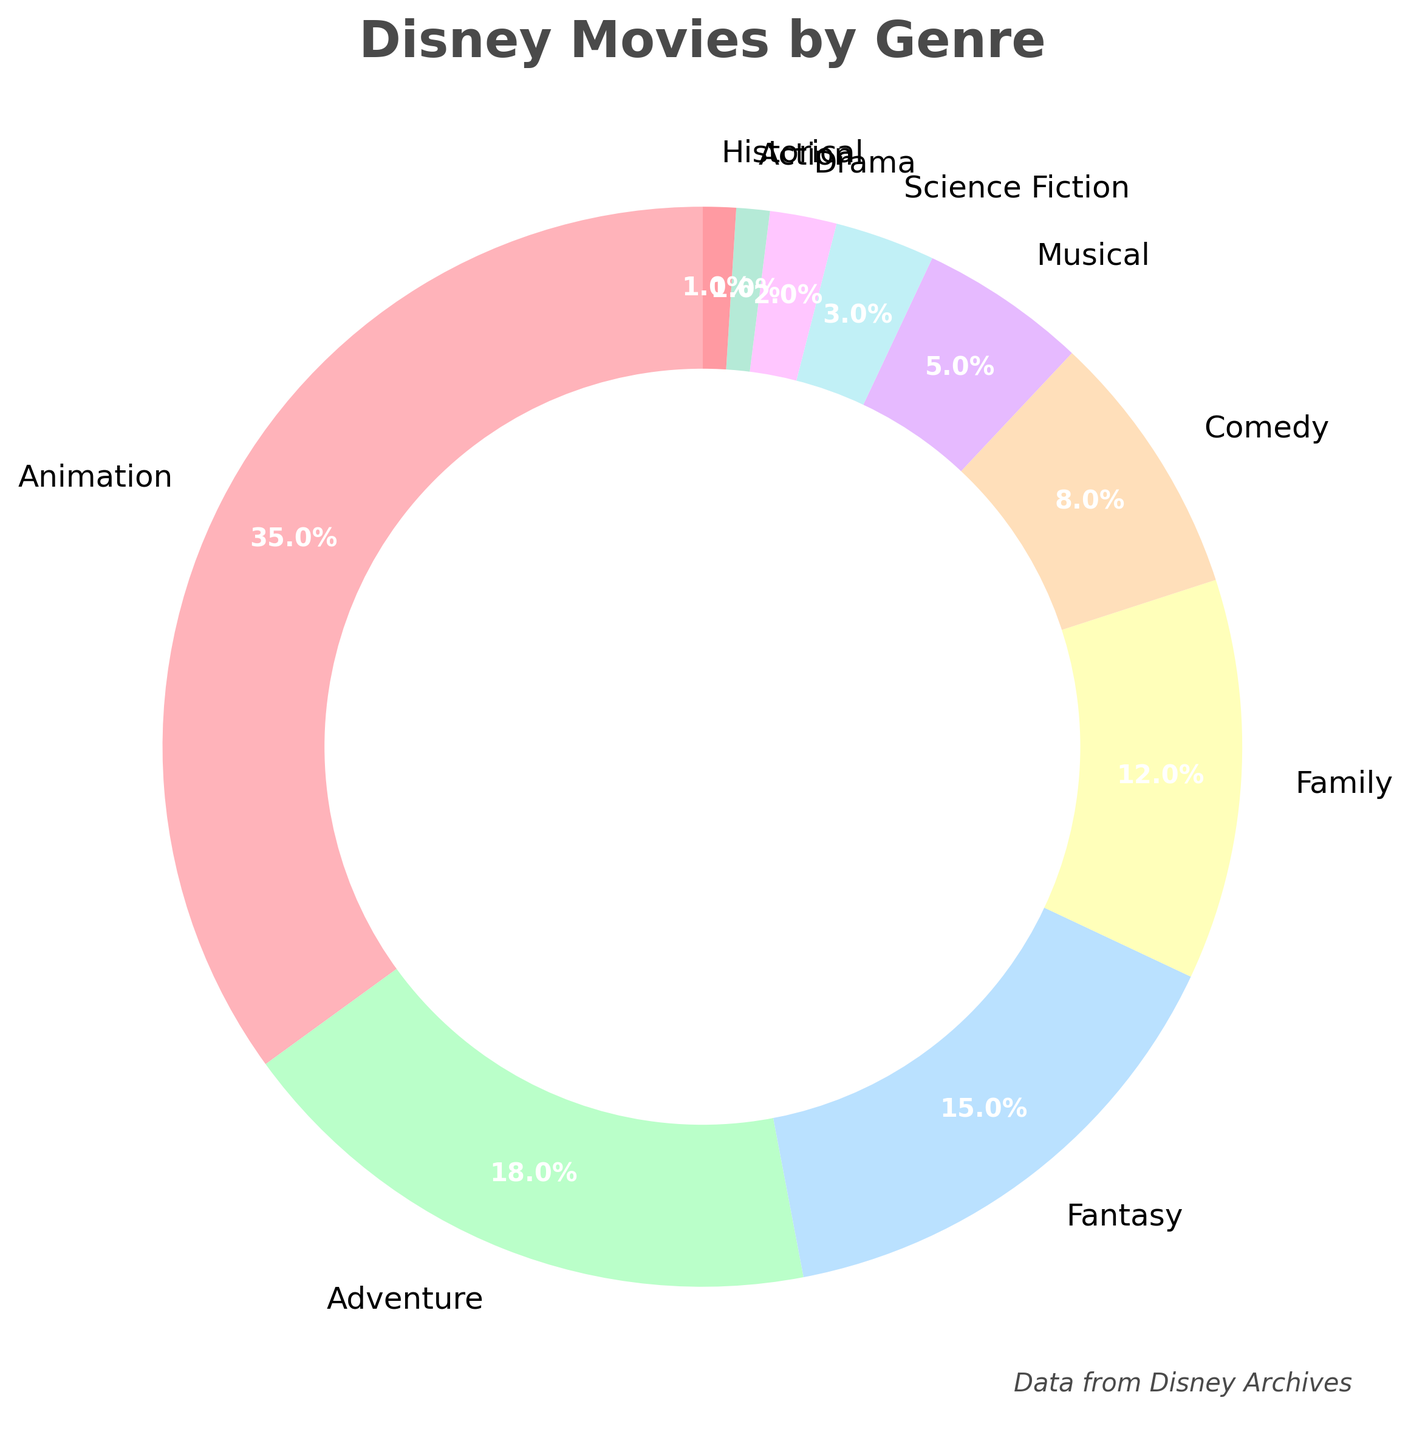What is the genre with the highest percentage? The genre with the highest percentage is determined by identifying the largest slice in the pie chart, which corresponds to "Animation" with a percentage of 35%.
Answer: Animation What is the total percentage of Adventure and Fantasy genres combined? To find the combined percentage, add the percentages of the Adventure (18%) and Fantasy (15%) genres: 18% + 15% = 33%.
Answer: 33% Which genre has a smaller percentage, Musical or Science Fiction? Compare the percentages of Musical (5%) and Science Fiction (3%). Since 3% is smaller than 5%, Science Fiction has the smaller percentage.
Answer: Science Fiction How much larger is the percentage of Family genre compared to Drama genre? Subtract the percentage of Drama (2%) from the percentage of Family (12%): 12% - 2% = 10%.
Answer: 10% What is the average percentage of the top three genres? The top three genres are Animation (35%), Adventure (18%), and Fantasy (15%). To find the average, sum these percentages and divide by 3: (35% + 18% + 15%) / 3 = 68% / 3 ≈ 22.67%.
Answer: 22.67% Which genre is represented by the yellow slice in the pie chart? The yellow slice represents the "Fantasy" genre as it is placed in the corresponding position on the pie chart.
Answer: Fantasy What is the combined percentage of the genres that have less than 5% each? The genres with less than 5% are Science Fiction (3%), Drama (2%), Action (1%), and Historical (1%). Adding these together: 3% + 2% + 1% + 1% = 7%.
Answer: 7% How much greater is the percentage of Animation compared to Comedy? Subtract the percentage of Comedy (8%) from Animation (35%): 35% - 8% = 27%.
Answer: 27% What is the sum of the percentages of genres that are greater than or equal to 10%? The genres with percentages greater than or equal to 10% are Animation (35%), Adventure (18%), Fantasy (15%), and Family (12%). Summing these percentages: 35% + 18% + 15% + 12% = 80%.
Answer: 80% Which genre has the smallest percentage? Identify the smallest slice in the pie chart, corresponding to "Historical" with a percentage of 1%.
Answer: Historical 